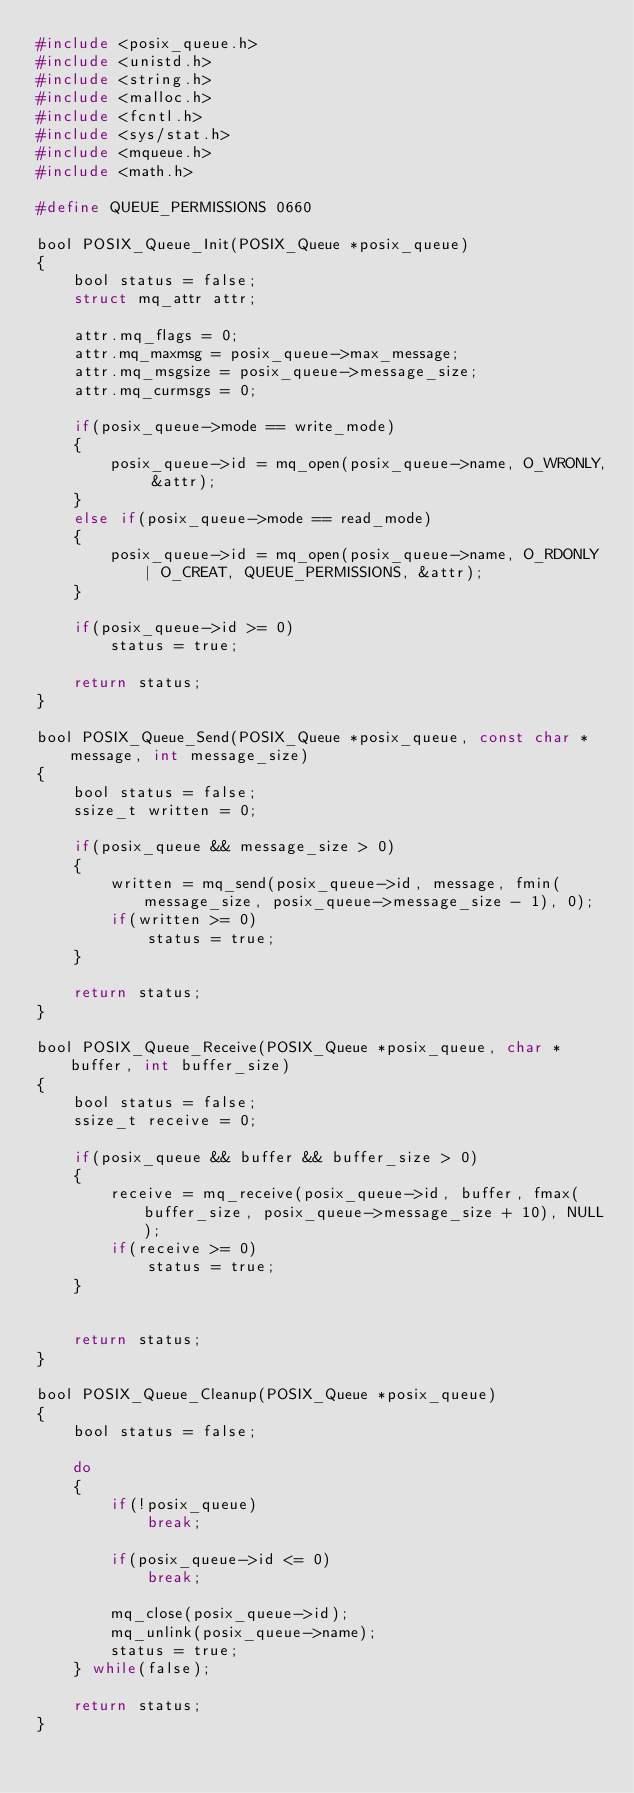Convert code to text. <code><loc_0><loc_0><loc_500><loc_500><_C_>#include <posix_queue.h>
#include <unistd.h>
#include <string.h>
#include <malloc.h>
#include <fcntl.h>
#include <sys/stat.h>
#include <mqueue.h>
#include <math.h>

#define QUEUE_PERMISSIONS 0660

bool POSIX_Queue_Init(POSIX_Queue *posix_queue)
{
    bool status = false;
    struct mq_attr attr;

    attr.mq_flags = 0;
    attr.mq_maxmsg = posix_queue->max_message;
    attr.mq_msgsize = posix_queue->message_size;
    attr.mq_curmsgs = 0;
    
    if(posix_queue->mode == write_mode)
    {
        posix_queue->id = mq_open(posix_queue->name, O_WRONLY, &attr);
    }
    else if(posix_queue->mode == read_mode)
    {   
        posix_queue->id = mq_open(posix_queue->name, O_RDONLY | O_CREAT, QUEUE_PERMISSIONS, &attr);
    }

    if(posix_queue->id >= 0)
        status = true;    

    return status;
}

bool POSIX_Queue_Send(POSIX_Queue *posix_queue, const char *message, int message_size)
{
    bool status = false;
    ssize_t written = 0;

    if(posix_queue && message_size > 0)
    {
        written = mq_send(posix_queue->id, message, fmin(message_size, posix_queue->message_size - 1), 0);
        if(written >= 0)
            status = true;
    }

    return status;
}

bool POSIX_Queue_Receive(POSIX_Queue *posix_queue, char *buffer, int buffer_size)
{
    bool status = false;
    ssize_t receive = 0;

    if(posix_queue && buffer && buffer_size > 0)
    {
        receive = mq_receive(posix_queue->id, buffer, fmax(buffer_size, posix_queue->message_size + 10), NULL);
        if(receive >= 0)
            status = true;
    }
        

    return status;
}

bool POSIX_Queue_Cleanup(POSIX_Queue *posix_queue)
{
    bool status = false;

    do 
    {
        if(!posix_queue)
            break;

        if(posix_queue->id <= 0)
            break;

        mq_close(posix_queue->id);
        mq_unlink(posix_queue->name);
        status = true;
    } while(false);

    return status;
}</code> 